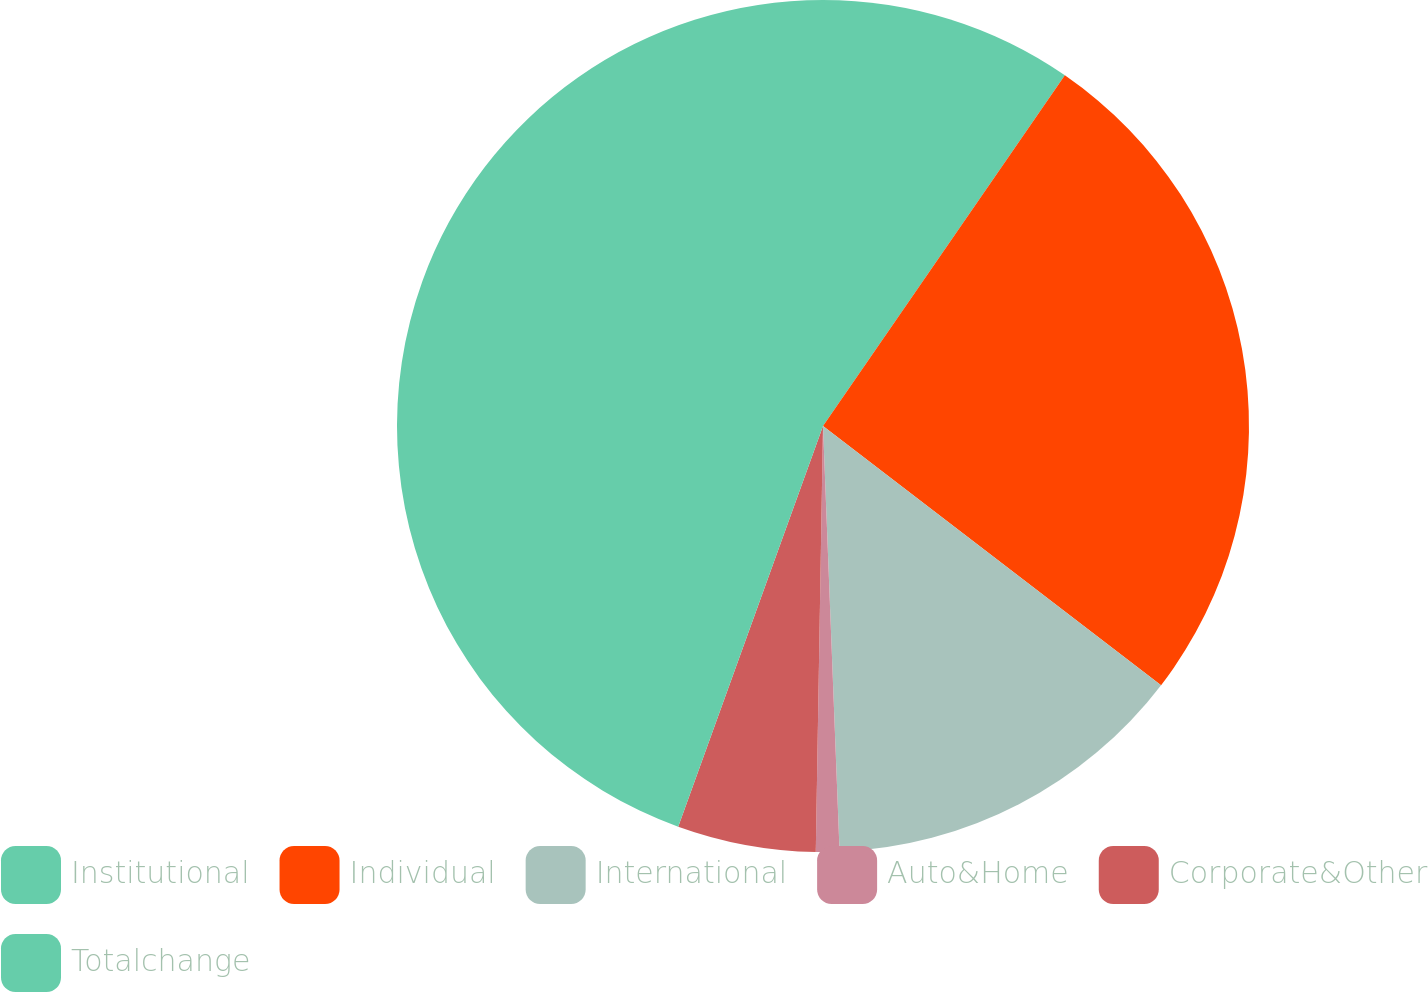Convert chart. <chart><loc_0><loc_0><loc_500><loc_500><pie_chart><fcel>Institutional<fcel>Individual<fcel>International<fcel>Auto&Home<fcel>Corporate&Other<fcel>Totalchange<nl><fcel>9.61%<fcel>25.8%<fcel>13.97%<fcel>0.89%<fcel>5.25%<fcel>44.48%<nl></chart> 